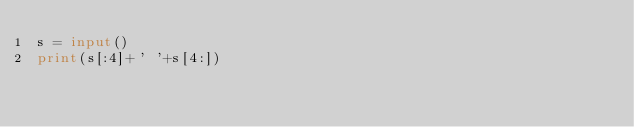<code> <loc_0><loc_0><loc_500><loc_500><_Python_>s = input()
print(s[:4]+' '+s[4:])</code> 